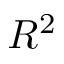<formula> <loc_0><loc_0><loc_500><loc_500>R ^ { 2 }</formula> 